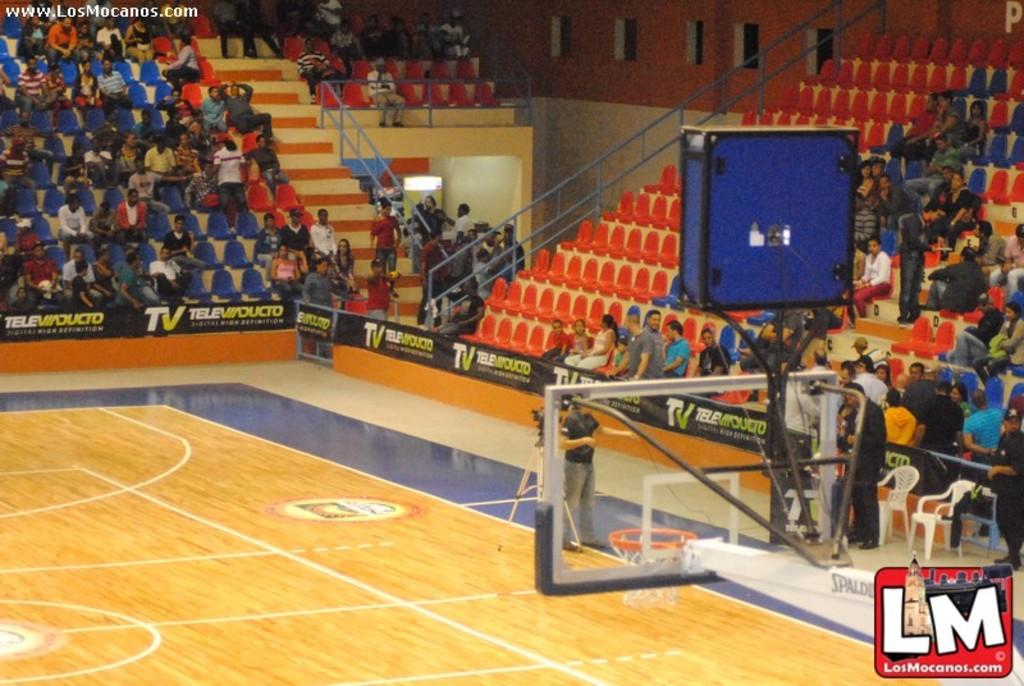What name is displayed on the banner?
Give a very brief answer. Tele ducto. 